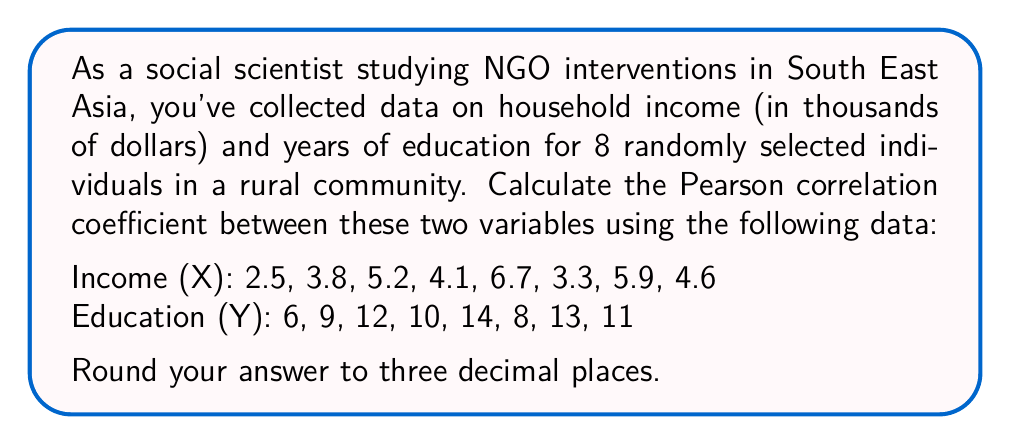Teach me how to tackle this problem. To calculate the Pearson correlation coefficient (r) between income (X) and education (Y), we'll use the formula:

$$ r = \frac{\sum_{i=1}^{n} (x_i - \bar{x})(y_i - \bar{y})}{\sqrt{\sum_{i=1}^{n} (x_i - \bar{x})^2 \sum_{i=1}^{n} (y_i - \bar{y})^2}} $$

Where $\bar{x}$ and $\bar{y}$ are the means of X and Y respectively.

Step 1: Calculate the means
$\bar{x} = \frac{2.5 + 3.8 + 5.2 + 4.1 + 6.7 + 3.3 + 5.9 + 4.6}{8} = 4.5125$
$\bar{y} = \frac{6 + 9 + 12 + 10 + 14 + 8 + 13 + 11}{8} = 10.375$

Step 2: Calculate $(x_i - \bar{x})$, $(y_i - \bar{y})$, $(x_i - \bar{x})^2$, $(y_i - \bar{y})^2$, and $(x_i - \bar{x})(y_i - \bar{y})$ for each pair of values.

Step 3: Sum the results from Step 2
$\sum (x_i - \bar{x})(y_i - \bar{y}) = 29.6875$
$\sum (x_i - \bar{x})^2 = 16.4844$
$\sum (y_i - \bar{y})^2 = 64.875$

Step 4: Apply the formula
$$ r = \frac{29.6875}{\sqrt{16.4844 \times 64.875}} = \frac{29.6875}{32.6935} = 0.9081 $$

Step 5: Round to three decimal places
$r \approx 0.908$
Answer: The Pearson correlation coefficient between household income and years of education in this community is approximately 0.908. 